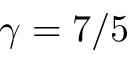<formula> <loc_0><loc_0><loc_500><loc_500>\gamma = 7 / 5</formula> 